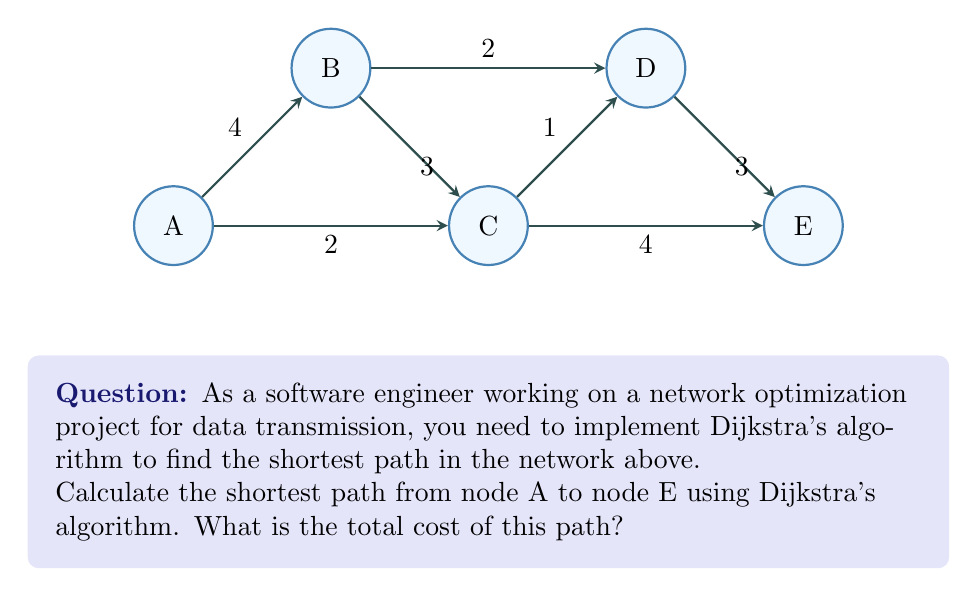What is the answer to this math problem? Let's apply Dijkstra's algorithm step by step:

1) Initialize:
   - Set distance to A as 0, all others as infinity.
   - Set all nodes as unvisited.
   - Set A as the current node.

2) For the current node, calculate tentative distances to its unvisited neighbors:
   - A to B: 0 + 4 = 4
   - A to C: 0 + 2 = 2
   Update distances if smaller than current recorded distance.

3) Mark A as visited. Set C (smallest tentative distance) as the current node.

4) From C, calculate:
   - C to B: 2 + 3 = 5 (larger than current B, ignore)
   - C to D: 2 + 1 = 3
   - C to E: 2 + 4 = 6

5) Mark C as visited. Set D (smallest tentative distance among unvisited) as current.

6) From D, calculate:
   - D to B: 3 + 2 = 5 (larger than current B, ignore)
   - D to E: 3 + 3 = 6

7) Mark D as visited. Set B (smallest tentative distance among unvisited) as current.

8) From B, no unvisited neighbors.

9) Mark B as visited. Set E (last unvisited) as current.

10) Algorithm complete. Shortest path found: A -> C -> D -> E
    Total cost: 0 + 2 + 1 + 3 = 6
Answer: 6 